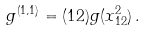<formula> <loc_0><loc_0><loc_500><loc_500>g ^ { ( 1 , 1 ) } = ( 1 2 ) g ( x _ { 1 2 } ^ { 2 } ) \, .</formula> 